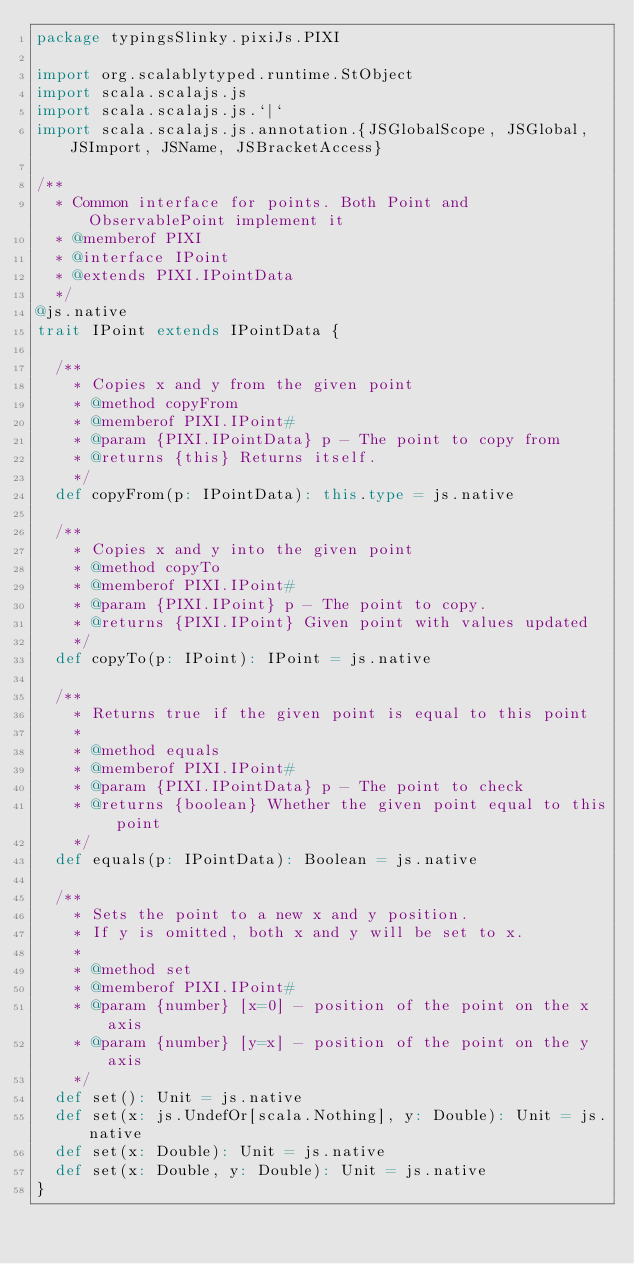Convert code to text. <code><loc_0><loc_0><loc_500><loc_500><_Scala_>package typingsSlinky.pixiJs.PIXI

import org.scalablytyped.runtime.StObject
import scala.scalajs.js
import scala.scalajs.js.`|`
import scala.scalajs.js.annotation.{JSGlobalScope, JSGlobal, JSImport, JSName, JSBracketAccess}

/**
  * Common interface for points. Both Point and ObservablePoint implement it
  * @memberof PIXI
  * @interface IPoint
  * @extends PIXI.IPointData
  */
@js.native
trait IPoint extends IPointData {
  
  /**
    * Copies x and y from the given point
    * @method copyFrom
    * @memberof PIXI.IPoint#
    * @param {PIXI.IPointData} p - The point to copy from
    * @returns {this} Returns itself.
    */
  def copyFrom(p: IPointData): this.type = js.native
  
  /**
    * Copies x and y into the given point
    * @method copyTo
    * @memberof PIXI.IPoint#
    * @param {PIXI.IPoint} p - The point to copy.
    * @returns {PIXI.IPoint} Given point with values updated
    */
  def copyTo(p: IPoint): IPoint = js.native
  
  /**
    * Returns true if the given point is equal to this point
    *
    * @method equals
    * @memberof PIXI.IPoint#
    * @param {PIXI.IPointData} p - The point to check
    * @returns {boolean} Whether the given point equal to this point
    */
  def equals(p: IPointData): Boolean = js.native
  
  /**
    * Sets the point to a new x and y position.
    * If y is omitted, both x and y will be set to x.
    *
    * @method set
    * @memberof PIXI.IPoint#
    * @param {number} [x=0] - position of the point on the x axis
    * @param {number} [y=x] - position of the point on the y axis
    */
  def set(): Unit = js.native
  def set(x: js.UndefOr[scala.Nothing], y: Double): Unit = js.native
  def set(x: Double): Unit = js.native
  def set(x: Double, y: Double): Unit = js.native
}
</code> 